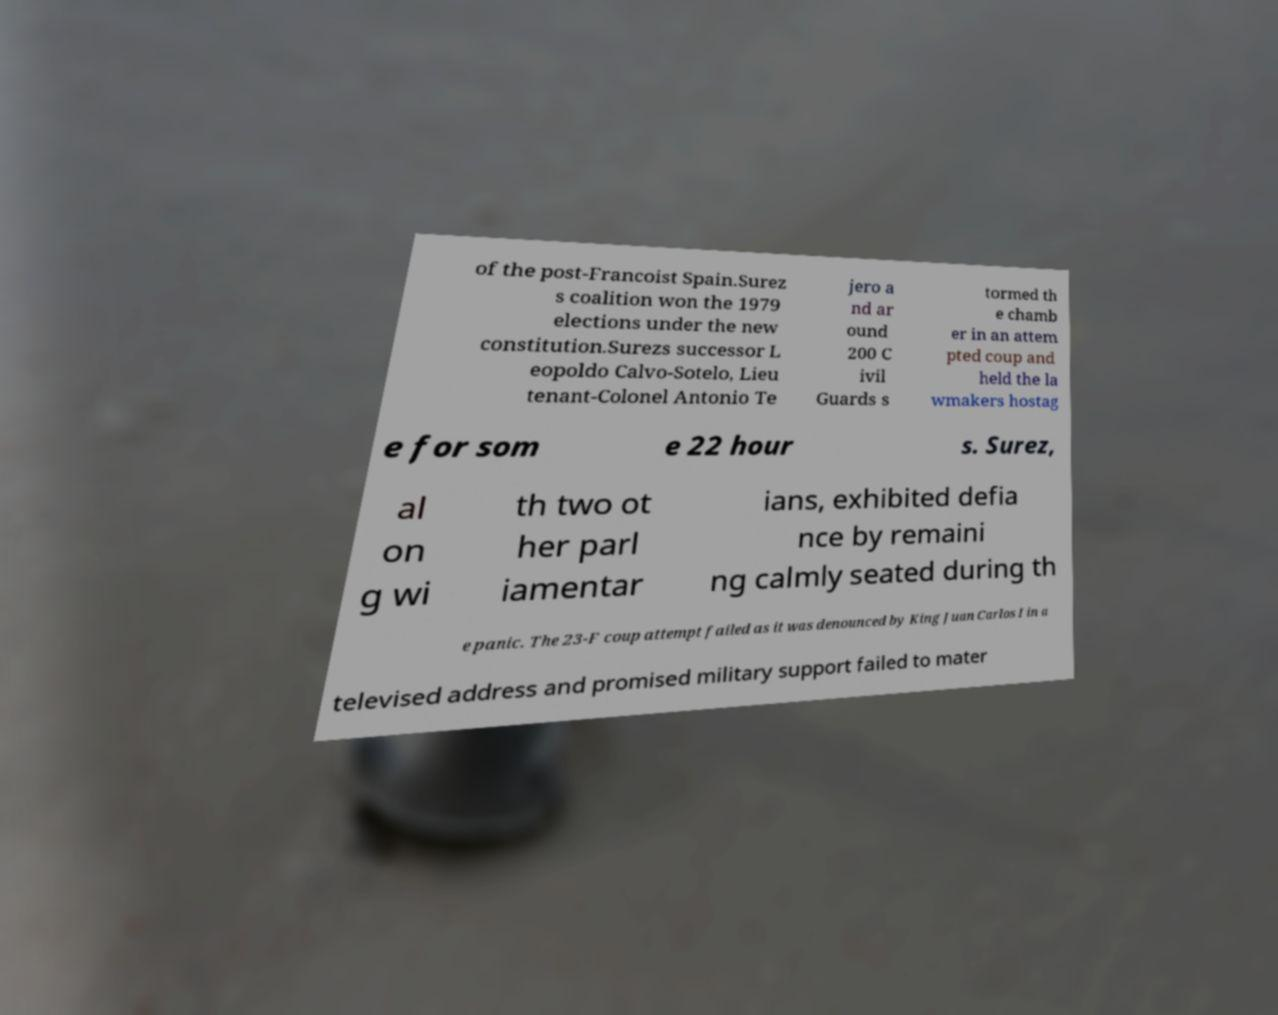Can you read and provide the text displayed in the image?This photo seems to have some interesting text. Can you extract and type it out for me? of the post-Francoist Spain.Surez s coalition won the 1979 elections under the new constitution.Surezs successor L eopoldo Calvo-Sotelo, Lieu tenant-Colonel Antonio Te jero a nd ar ound 200 C ivil Guards s tormed th e chamb er in an attem pted coup and held the la wmakers hostag e for som e 22 hour s. Surez, al on g wi th two ot her parl iamentar ians, exhibited defia nce by remaini ng calmly seated during th e panic. The 23-F coup attempt failed as it was denounced by King Juan Carlos I in a televised address and promised military support failed to mater 